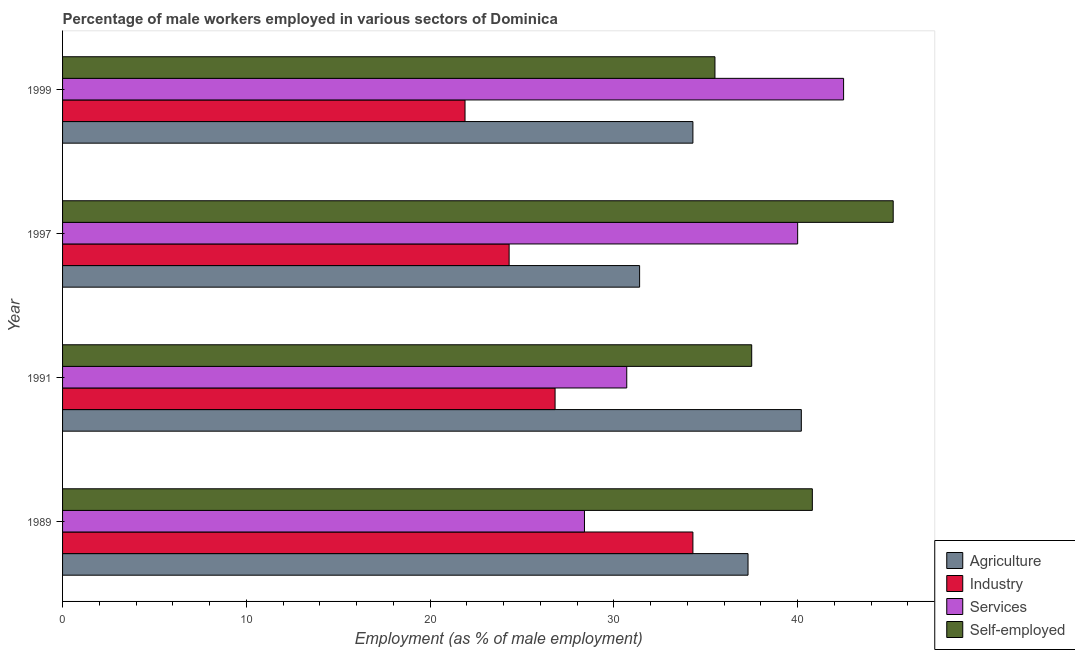How many groups of bars are there?
Give a very brief answer. 4. How many bars are there on the 3rd tick from the top?
Keep it short and to the point. 4. In how many cases, is the number of bars for a given year not equal to the number of legend labels?
Make the answer very short. 0. What is the percentage of male workers in industry in 1997?
Ensure brevity in your answer.  24.3. Across all years, what is the maximum percentage of self employed male workers?
Make the answer very short. 45.2. Across all years, what is the minimum percentage of male workers in services?
Your answer should be compact. 28.4. In which year was the percentage of male workers in agriculture minimum?
Ensure brevity in your answer.  1997. What is the total percentage of male workers in industry in the graph?
Your answer should be compact. 107.3. What is the difference between the percentage of male workers in agriculture in 1989 and that in 1999?
Provide a succinct answer. 3. What is the difference between the percentage of male workers in services in 1997 and the percentage of self employed male workers in 1989?
Ensure brevity in your answer.  -0.8. What is the average percentage of self employed male workers per year?
Your answer should be very brief. 39.75. In how many years, is the percentage of male workers in industry greater than 2 %?
Make the answer very short. 4. What is the ratio of the percentage of self employed male workers in 1989 to that in 1997?
Make the answer very short. 0.9. In how many years, is the percentage of male workers in agriculture greater than the average percentage of male workers in agriculture taken over all years?
Offer a very short reply. 2. Is it the case that in every year, the sum of the percentage of male workers in industry and percentage of self employed male workers is greater than the sum of percentage of male workers in agriculture and percentage of male workers in services?
Make the answer very short. Yes. What does the 1st bar from the top in 1999 represents?
Provide a succinct answer. Self-employed. What does the 1st bar from the bottom in 1991 represents?
Make the answer very short. Agriculture. Is it the case that in every year, the sum of the percentage of male workers in agriculture and percentage of male workers in industry is greater than the percentage of male workers in services?
Your response must be concise. Yes. How many bars are there?
Provide a succinct answer. 16. Are all the bars in the graph horizontal?
Make the answer very short. Yes. How many years are there in the graph?
Your response must be concise. 4. Does the graph contain any zero values?
Offer a terse response. No. Does the graph contain grids?
Offer a terse response. No. Where does the legend appear in the graph?
Ensure brevity in your answer.  Bottom right. How many legend labels are there?
Your answer should be compact. 4. What is the title of the graph?
Provide a short and direct response. Percentage of male workers employed in various sectors of Dominica. Does "Fish species" appear as one of the legend labels in the graph?
Provide a short and direct response. No. What is the label or title of the X-axis?
Provide a short and direct response. Employment (as % of male employment). What is the label or title of the Y-axis?
Keep it short and to the point. Year. What is the Employment (as % of male employment) in Agriculture in 1989?
Keep it short and to the point. 37.3. What is the Employment (as % of male employment) in Industry in 1989?
Keep it short and to the point. 34.3. What is the Employment (as % of male employment) of Services in 1989?
Your response must be concise. 28.4. What is the Employment (as % of male employment) of Self-employed in 1989?
Offer a very short reply. 40.8. What is the Employment (as % of male employment) in Agriculture in 1991?
Make the answer very short. 40.2. What is the Employment (as % of male employment) of Industry in 1991?
Your answer should be compact. 26.8. What is the Employment (as % of male employment) of Services in 1991?
Keep it short and to the point. 30.7. What is the Employment (as % of male employment) in Self-employed in 1991?
Keep it short and to the point. 37.5. What is the Employment (as % of male employment) in Agriculture in 1997?
Make the answer very short. 31.4. What is the Employment (as % of male employment) of Industry in 1997?
Offer a very short reply. 24.3. What is the Employment (as % of male employment) in Self-employed in 1997?
Ensure brevity in your answer.  45.2. What is the Employment (as % of male employment) of Agriculture in 1999?
Provide a succinct answer. 34.3. What is the Employment (as % of male employment) in Industry in 1999?
Provide a short and direct response. 21.9. What is the Employment (as % of male employment) of Services in 1999?
Offer a terse response. 42.5. What is the Employment (as % of male employment) in Self-employed in 1999?
Offer a very short reply. 35.5. Across all years, what is the maximum Employment (as % of male employment) in Agriculture?
Offer a terse response. 40.2. Across all years, what is the maximum Employment (as % of male employment) of Industry?
Offer a terse response. 34.3. Across all years, what is the maximum Employment (as % of male employment) in Services?
Offer a terse response. 42.5. Across all years, what is the maximum Employment (as % of male employment) of Self-employed?
Provide a short and direct response. 45.2. Across all years, what is the minimum Employment (as % of male employment) of Agriculture?
Give a very brief answer. 31.4. Across all years, what is the minimum Employment (as % of male employment) in Industry?
Offer a very short reply. 21.9. Across all years, what is the minimum Employment (as % of male employment) of Services?
Provide a short and direct response. 28.4. Across all years, what is the minimum Employment (as % of male employment) of Self-employed?
Offer a very short reply. 35.5. What is the total Employment (as % of male employment) in Agriculture in the graph?
Offer a very short reply. 143.2. What is the total Employment (as % of male employment) in Industry in the graph?
Your answer should be very brief. 107.3. What is the total Employment (as % of male employment) of Services in the graph?
Provide a succinct answer. 141.6. What is the total Employment (as % of male employment) of Self-employed in the graph?
Provide a short and direct response. 159. What is the difference between the Employment (as % of male employment) of Services in 1989 and that in 1991?
Provide a succinct answer. -2.3. What is the difference between the Employment (as % of male employment) of Self-employed in 1989 and that in 1991?
Keep it short and to the point. 3.3. What is the difference between the Employment (as % of male employment) of Agriculture in 1989 and that in 1997?
Keep it short and to the point. 5.9. What is the difference between the Employment (as % of male employment) in Agriculture in 1989 and that in 1999?
Offer a terse response. 3. What is the difference between the Employment (as % of male employment) of Industry in 1989 and that in 1999?
Offer a very short reply. 12.4. What is the difference between the Employment (as % of male employment) in Services in 1989 and that in 1999?
Your answer should be very brief. -14.1. What is the difference between the Employment (as % of male employment) in Agriculture in 1991 and that in 1997?
Your answer should be compact. 8.8. What is the difference between the Employment (as % of male employment) of Services in 1991 and that in 1997?
Provide a succinct answer. -9.3. What is the difference between the Employment (as % of male employment) of Industry in 1991 and that in 1999?
Your response must be concise. 4.9. What is the difference between the Employment (as % of male employment) in Agriculture in 1989 and the Employment (as % of male employment) in Industry in 1991?
Your answer should be very brief. 10.5. What is the difference between the Employment (as % of male employment) of Industry in 1989 and the Employment (as % of male employment) of Services in 1991?
Provide a short and direct response. 3.6. What is the difference between the Employment (as % of male employment) in Industry in 1989 and the Employment (as % of male employment) in Self-employed in 1991?
Your answer should be very brief. -3.2. What is the difference between the Employment (as % of male employment) in Services in 1989 and the Employment (as % of male employment) in Self-employed in 1991?
Keep it short and to the point. -9.1. What is the difference between the Employment (as % of male employment) of Agriculture in 1989 and the Employment (as % of male employment) of Self-employed in 1997?
Keep it short and to the point. -7.9. What is the difference between the Employment (as % of male employment) in Industry in 1989 and the Employment (as % of male employment) in Self-employed in 1997?
Keep it short and to the point. -10.9. What is the difference between the Employment (as % of male employment) of Services in 1989 and the Employment (as % of male employment) of Self-employed in 1997?
Your response must be concise. -16.8. What is the difference between the Employment (as % of male employment) in Agriculture in 1989 and the Employment (as % of male employment) in Industry in 1999?
Your response must be concise. 15.4. What is the difference between the Employment (as % of male employment) in Agriculture in 1989 and the Employment (as % of male employment) in Services in 1999?
Your response must be concise. -5.2. What is the difference between the Employment (as % of male employment) of Agriculture in 1989 and the Employment (as % of male employment) of Self-employed in 1999?
Offer a very short reply. 1.8. What is the difference between the Employment (as % of male employment) in Industry in 1989 and the Employment (as % of male employment) in Services in 1999?
Provide a succinct answer. -8.2. What is the difference between the Employment (as % of male employment) in Industry in 1989 and the Employment (as % of male employment) in Self-employed in 1999?
Ensure brevity in your answer.  -1.2. What is the difference between the Employment (as % of male employment) in Agriculture in 1991 and the Employment (as % of male employment) in Industry in 1997?
Ensure brevity in your answer.  15.9. What is the difference between the Employment (as % of male employment) of Industry in 1991 and the Employment (as % of male employment) of Self-employed in 1997?
Your answer should be very brief. -18.4. What is the difference between the Employment (as % of male employment) of Services in 1991 and the Employment (as % of male employment) of Self-employed in 1997?
Make the answer very short. -14.5. What is the difference between the Employment (as % of male employment) in Agriculture in 1991 and the Employment (as % of male employment) in Services in 1999?
Your response must be concise. -2.3. What is the difference between the Employment (as % of male employment) in Agriculture in 1991 and the Employment (as % of male employment) in Self-employed in 1999?
Offer a very short reply. 4.7. What is the difference between the Employment (as % of male employment) in Industry in 1991 and the Employment (as % of male employment) in Services in 1999?
Keep it short and to the point. -15.7. What is the difference between the Employment (as % of male employment) in Agriculture in 1997 and the Employment (as % of male employment) in Industry in 1999?
Your answer should be compact. 9.5. What is the difference between the Employment (as % of male employment) in Agriculture in 1997 and the Employment (as % of male employment) in Services in 1999?
Give a very brief answer. -11.1. What is the difference between the Employment (as % of male employment) of Industry in 1997 and the Employment (as % of male employment) of Services in 1999?
Offer a terse response. -18.2. What is the difference between the Employment (as % of male employment) of Industry in 1997 and the Employment (as % of male employment) of Self-employed in 1999?
Offer a terse response. -11.2. What is the difference between the Employment (as % of male employment) of Services in 1997 and the Employment (as % of male employment) of Self-employed in 1999?
Your answer should be compact. 4.5. What is the average Employment (as % of male employment) in Agriculture per year?
Your answer should be very brief. 35.8. What is the average Employment (as % of male employment) in Industry per year?
Offer a terse response. 26.82. What is the average Employment (as % of male employment) in Services per year?
Provide a succinct answer. 35.4. What is the average Employment (as % of male employment) of Self-employed per year?
Your answer should be very brief. 39.75. In the year 1989, what is the difference between the Employment (as % of male employment) in Agriculture and Employment (as % of male employment) in Industry?
Your response must be concise. 3. In the year 1989, what is the difference between the Employment (as % of male employment) of Agriculture and Employment (as % of male employment) of Services?
Give a very brief answer. 8.9. In the year 1989, what is the difference between the Employment (as % of male employment) of Agriculture and Employment (as % of male employment) of Self-employed?
Give a very brief answer. -3.5. In the year 1989, what is the difference between the Employment (as % of male employment) in Industry and Employment (as % of male employment) in Services?
Ensure brevity in your answer.  5.9. In the year 1989, what is the difference between the Employment (as % of male employment) of Industry and Employment (as % of male employment) of Self-employed?
Your response must be concise. -6.5. In the year 1991, what is the difference between the Employment (as % of male employment) in Agriculture and Employment (as % of male employment) in Services?
Ensure brevity in your answer.  9.5. In the year 1991, what is the difference between the Employment (as % of male employment) in Services and Employment (as % of male employment) in Self-employed?
Your answer should be compact. -6.8. In the year 1997, what is the difference between the Employment (as % of male employment) in Agriculture and Employment (as % of male employment) in Services?
Your answer should be very brief. -8.6. In the year 1997, what is the difference between the Employment (as % of male employment) of Industry and Employment (as % of male employment) of Services?
Make the answer very short. -15.7. In the year 1997, what is the difference between the Employment (as % of male employment) in Industry and Employment (as % of male employment) in Self-employed?
Your response must be concise. -20.9. In the year 1999, what is the difference between the Employment (as % of male employment) in Agriculture and Employment (as % of male employment) in Self-employed?
Ensure brevity in your answer.  -1.2. In the year 1999, what is the difference between the Employment (as % of male employment) in Industry and Employment (as % of male employment) in Services?
Provide a succinct answer. -20.6. In the year 1999, what is the difference between the Employment (as % of male employment) in Services and Employment (as % of male employment) in Self-employed?
Offer a very short reply. 7. What is the ratio of the Employment (as % of male employment) of Agriculture in 1989 to that in 1991?
Ensure brevity in your answer.  0.93. What is the ratio of the Employment (as % of male employment) of Industry in 1989 to that in 1991?
Provide a succinct answer. 1.28. What is the ratio of the Employment (as % of male employment) of Services in 1989 to that in 1991?
Give a very brief answer. 0.93. What is the ratio of the Employment (as % of male employment) of Self-employed in 1989 to that in 1991?
Your answer should be very brief. 1.09. What is the ratio of the Employment (as % of male employment) of Agriculture in 1989 to that in 1997?
Give a very brief answer. 1.19. What is the ratio of the Employment (as % of male employment) of Industry in 1989 to that in 1997?
Ensure brevity in your answer.  1.41. What is the ratio of the Employment (as % of male employment) of Services in 1989 to that in 1997?
Your answer should be very brief. 0.71. What is the ratio of the Employment (as % of male employment) in Self-employed in 1989 to that in 1997?
Offer a very short reply. 0.9. What is the ratio of the Employment (as % of male employment) of Agriculture in 1989 to that in 1999?
Your response must be concise. 1.09. What is the ratio of the Employment (as % of male employment) in Industry in 1989 to that in 1999?
Offer a very short reply. 1.57. What is the ratio of the Employment (as % of male employment) in Services in 1989 to that in 1999?
Offer a terse response. 0.67. What is the ratio of the Employment (as % of male employment) of Self-employed in 1989 to that in 1999?
Offer a very short reply. 1.15. What is the ratio of the Employment (as % of male employment) of Agriculture in 1991 to that in 1997?
Offer a very short reply. 1.28. What is the ratio of the Employment (as % of male employment) in Industry in 1991 to that in 1997?
Your answer should be very brief. 1.1. What is the ratio of the Employment (as % of male employment) of Services in 1991 to that in 1997?
Provide a succinct answer. 0.77. What is the ratio of the Employment (as % of male employment) in Self-employed in 1991 to that in 1997?
Keep it short and to the point. 0.83. What is the ratio of the Employment (as % of male employment) of Agriculture in 1991 to that in 1999?
Make the answer very short. 1.17. What is the ratio of the Employment (as % of male employment) in Industry in 1991 to that in 1999?
Offer a terse response. 1.22. What is the ratio of the Employment (as % of male employment) in Services in 1991 to that in 1999?
Provide a succinct answer. 0.72. What is the ratio of the Employment (as % of male employment) of Self-employed in 1991 to that in 1999?
Provide a succinct answer. 1.06. What is the ratio of the Employment (as % of male employment) in Agriculture in 1997 to that in 1999?
Your answer should be very brief. 0.92. What is the ratio of the Employment (as % of male employment) in Industry in 1997 to that in 1999?
Offer a terse response. 1.11. What is the ratio of the Employment (as % of male employment) in Self-employed in 1997 to that in 1999?
Provide a succinct answer. 1.27. What is the difference between the highest and the second highest Employment (as % of male employment) in Agriculture?
Your response must be concise. 2.9. What is the difference between the highest and the second highest Employment (as % of male employment) of Industry?
Provide a short and direct response. 7.5. What is the difference between the highest and the second highest Employment (as % of male employment) of Self-employed?
Offer a terse response. 4.4. What is the difference between the highest and the lowest Employment (as % of male employment) of Agriculture?
Your response must be concise. 8.8. What is the difference between the highest and the lowest Employment (as % of male employment) in Industry?
Provide a succinct answer. 12.4. 